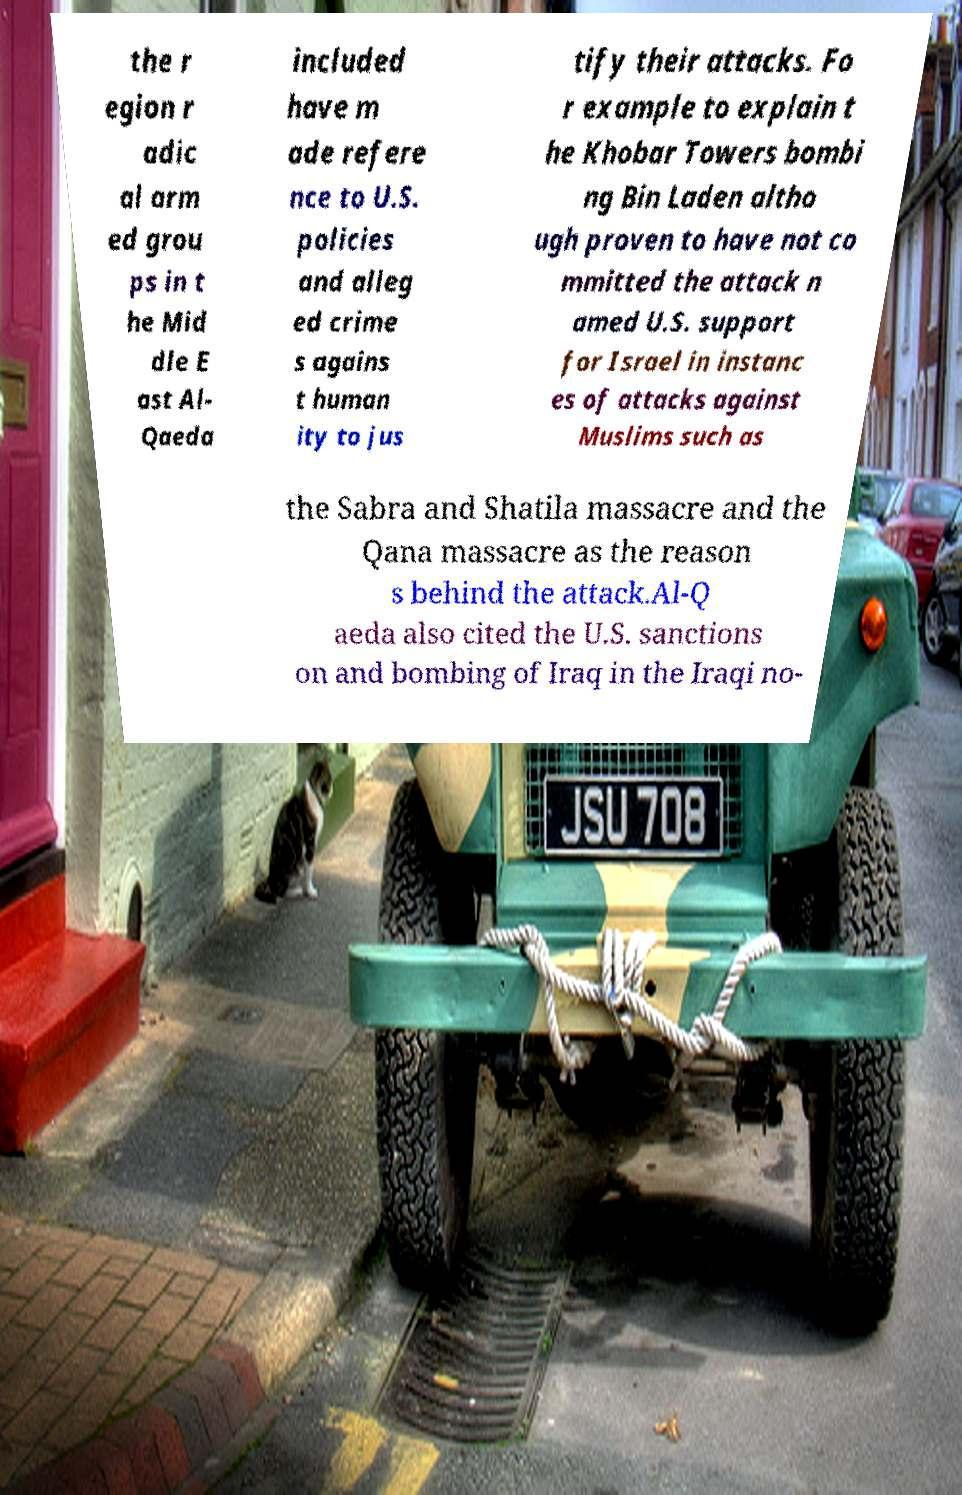I need the written content from this picture converted into text. Can you do that? the r egion r adic al arm ed grou ps in t he Mid dle E ast Al- Qaeda included have m ade refere nce to U.S. policies and alleg ed crime s agains t human ity to jus tify their attacks. Fo r example to explain t he Khobar Towers bombi ng Bin Laden altho ugh proven to have not co mmitted the attack n amed U.S. support for Israel in instanc es of attacks against Muslims such as the Sabra and Shatila massacre and the Qana massacre as the reason s behind the attack.Al-Q aeda also cited the U.S. sanctions on and bombing of Iraq in the Iraqi no- 